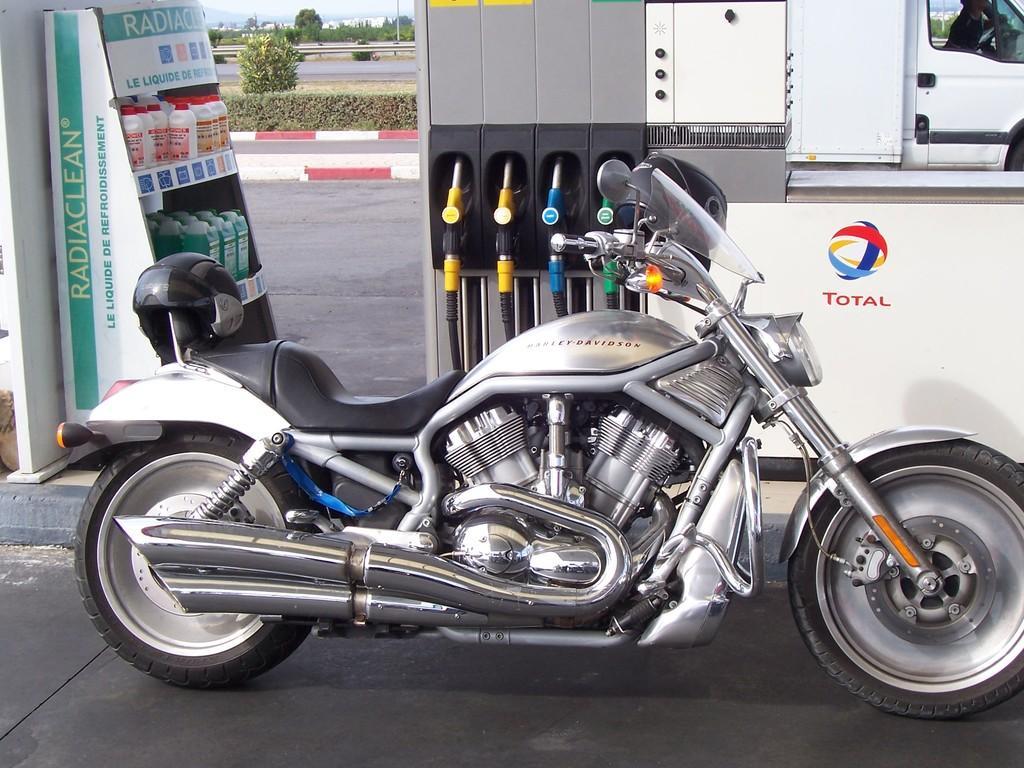In one or two sentences, can you explain what this image depicts? In this image I can see a bike in silver and black color. Background I can see trees in green color, few bottles and sky in white color. 